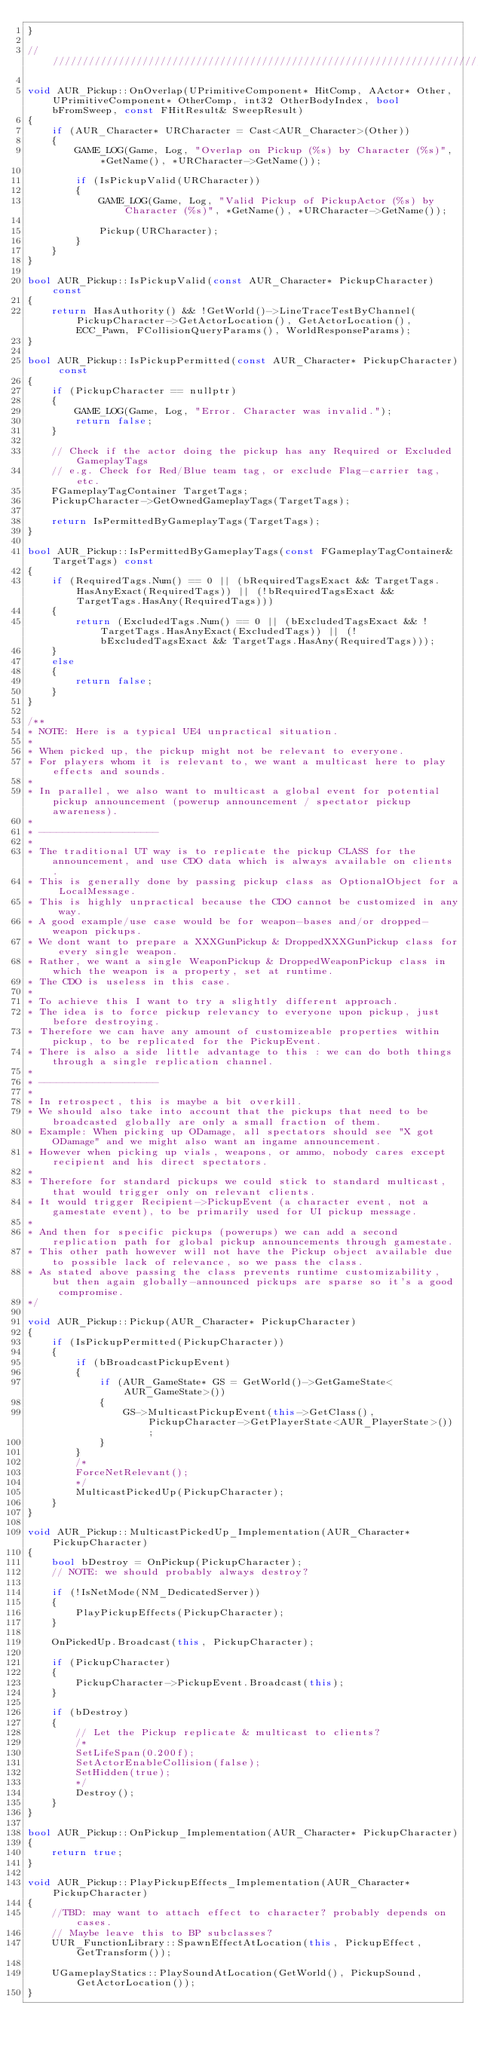Convert code to text. <code><loc_0><loc_0><loc_500><loc_500><_C++_>}

/////////////////////////////////////////////////////////////////////////////////////////////////

void AUR_Pickup::OnOverlap(UPrimitiveComponent* HitComp, AActor* Other, UPrimitiveComponent* OtherComp, int32 OtherBodyIndex, bool bFromSweep, const FHitResult& SweepResult)
{
    if (AUR_Character* URCharacter = Cast<AUR_Character>(Other))
    {
        GAME_LOG(Game, Log, "Overlap on Pickup (%s) by Character (%s)", *GetName(), *URCharacter->GetName());

        if (IsPickupValid(URCharacter))
        {
            GAME_LOG(Game, Log, "Valid Pickup of PickupActor (%s) by Character (%s)", *GetName(), *URCharacter->GetName());

            Pickup(URCharacter);
        }
    }
}

bool AUR_Pickup::IsPickupValid(const AUR_Character* PickupCharacter) const
{
    return HasAuthority() && !GetWorld()->LineTraceTestByChannel(PickupCharacter->GetActorLocation(), GetActorLocation(), ECC_Pawn, FCollisionQueryParams(), WorldResponseParams);
}

bool AUR_Pickup::IsPickupPermitted(const AUR_Character* PickupCharacter) const
{
    if (PickupCharacter == nullptr)
    {
        GAME_LOG(Game, Log, "Error. Character was invalid.");
        return false;
    }

    // Check if the actor doing the pickup has any Required or Excluded GameplayTags
    // e.g. Check for Red/Blue team tag, or exclude Flag-carrier tag, etc.
    FGameplayTagContainer TargetTags;
    PickupCharacter->GetOwnedGameplayTags(TargetTags);

    return IsPermittedByGameplayTags(TargetTags);
}

bool AUR_Pickup::IsPermittedByGameplayTags(const FGameplayTagContainer& TargetTags) const
{
    if (RequiredTags.Num() == 0 || (bRequiredTagsExact && TargetTags.HasAnyExact(RequiredTags)) || (!bRequiredTagsExact && TargetTags.HasAny(RequiredTags)))
    {
        return (ExcludedTags.Num() == 0 || (bExcludedTagsExact && !TargetTags.HasAnyExact(ExcludedTags)) || (!bExcludedTagsExact && TargetTags.HasAny(RequiredTags)));
    }
    else
    {
        return false;
    }
}

/**
* NOTE: Here is a typical UE4 unpractical situation.
*
* When picked up, the pickup might not be relevant to everyone.
* For players whom it is relevant to, we want a multicast here to play effects and sounds.
*
* In parallel, we also want to multicast a global event for potential pickup announcement (powerup announcement / spectator pickup awareness).
*
* --------------------
*
* The traditional UT way is to replicate the pickup CLASS for the announcement, and use CDO data which is always available on clients.
* This is generally done by passing pickup class as OptionalObject for a LocalMessage.
* This is highly unpractical because the CDO cannot be customized in any way.
* A good example/use case would be for weapon-bases and/or dropped-weapon pickups.
* We dont want to prepare a XXXGunPickup & DroppedXXXGunPickup class for every single weapon.
* Rather, we want a single WeaponPickup & DroppedWeaponPickup class in which the weapon is a property, set at runtime.
* The CDO is useless in this case.
*
* To achieve this I want to try a slightly different approach.
* The idea is to force pickup relevancy to everyone upon pickup, just before destroying.
* Therefore we can have any amount of customizeable properties within pickup, to be replicated for the PickupEvent.
* There is also a side little advantage to this : we can do both things through a single replication channel.
*
* --------------------
*
* In retrospect, this is maybe a bit overkill.
* We should also take into account that the pickups that need to be broadcasted globally are only a small fraction of them.
* Example: When picking up ODamage, all spectators should see "X got ODamage" and we might also want an ingame announcement.
* However when picking up vials, weapons, or ammo, nobody cares except recipient and his direct spectators.
* 
* Therefore for standard pickups we could stick to standard multicast, that would trigger only on relevant clients.
* It would trigger Recipient->PickupEvent (a character event, not a gamestate event), to be primarily used for UI pickup message.
* 
* And then for specific pickups (powerups) we can add a second replication path for global pickup announcements through gamestate.
* This other path however will not have the Pickup object available due to possible lack of relevance, so we pass the class.
* As stated above passing the class prevents runtime customizability, but then again globally-announced pickups are sparse so it's a good compromise.
*/

void AUR_Pickup::Pickup(AUR_Character* PickupCharacter)
{
    if (IsPickupPermitted(PickupCharacter))
    {
        if (bBroadcastPickupEvent)
        {
            if (AUR_GameState* GS = GetWorld()->GetGameState<AUR_GameState>())
            {
                GS->MulticastPickupEvent(this->GetClass(), PickupCharacter->GetPlayerState<AUR_PlayerState>());
            }
        }
        /*
        ForceNetRelevant();
        */
        MulticastPickedUp(PickupCharacter);
    }
}

void AUR_Pickup::MulticastPickedUp_Implementation(AUR_Character* PickupCharacter)
{
    bool bDestroy = OnPickup(PickupCharacter);
    // NOTE: we should probably always destroy?

    if (!IsNetMode(NM_DedicatedServer))
    {
        PlayPickupEffects(PickupCharacter);
    }

    OnPickedUp.Broadcast(this, PickupCharacter);

    if (PickupCharacter)
    {
        PickupCharacter->PickupEvent.Broadcast(this);
    }

    if (bDestroy)
    {
        // Let the Pickup replicate & multicast to clients?
        /*
        SetLifeSpan(0.200f);
        SetActorEnableCollision(false);
        SetHidden(true);
        */
        Destroy();
    }
}

bool AUR_Pickup::OnPickup_Implementation(AUR_Character* PickupCharacter)
{
    return true;
}

void AUR_Pickup::PlayPickupEffects_Implementation(AUR_Character* PickupCharacter)
{
    //TBD: may want to attach effect to character? probably depends on cases.
    // Maybe leave this to BP subclasses?
    UUR_FunctionLibrary::SpawnEffectAtLocation(this, PickupEffect, GetTransform());

    UGameplayStatics::PlaySoundAtLocation(GetWorld(), PickupSound, GetActorLocation());
}
</code> 